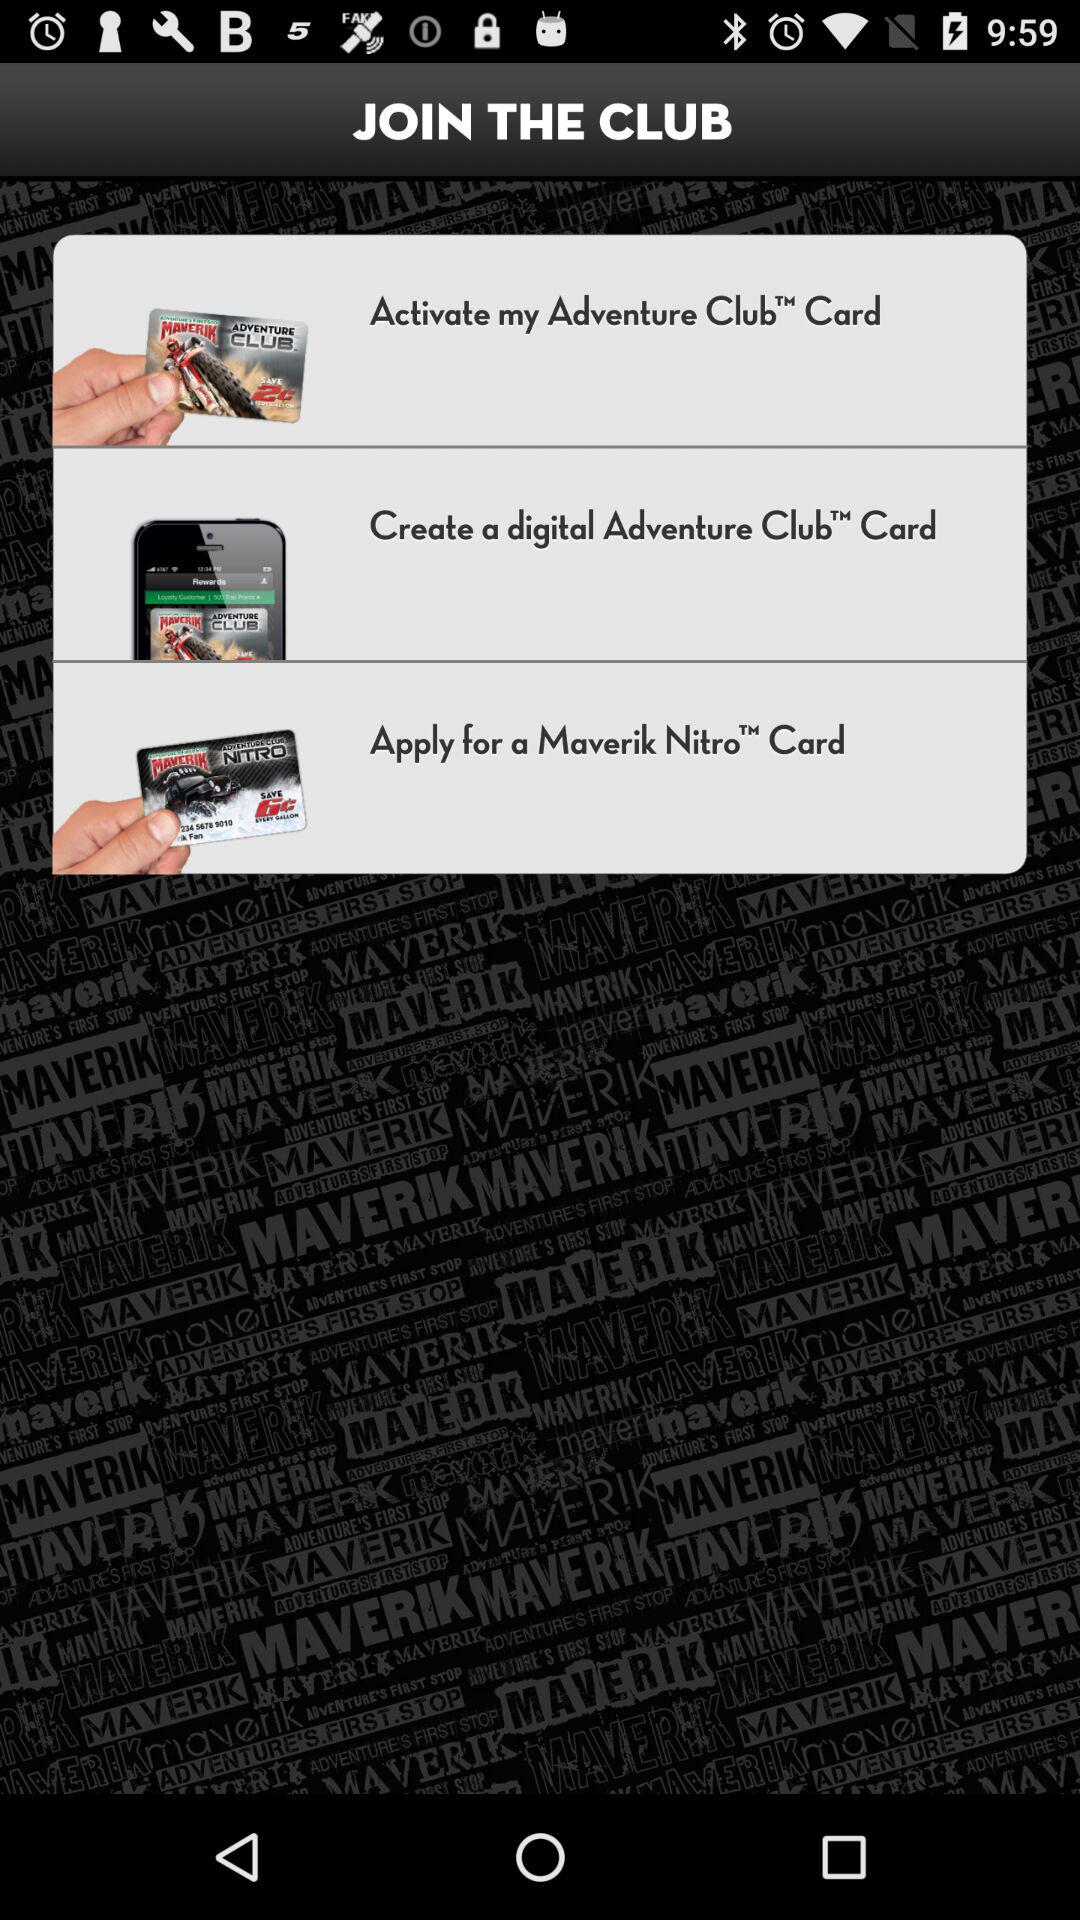How many types of cards are available? The available cards are: "Adventure Club Card", "digital Adventure Club Card", and "Maverik Nitro Card". 